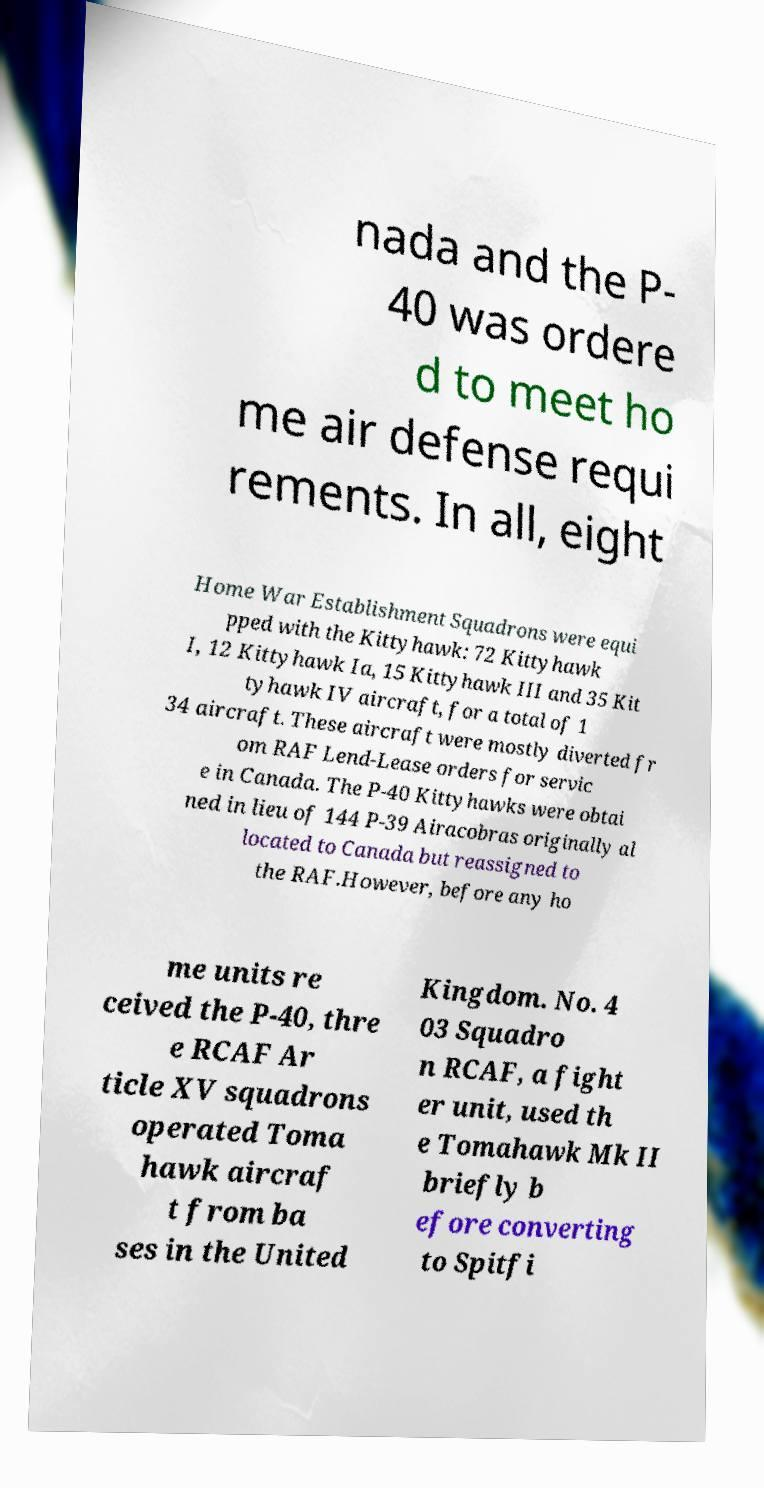Could you assist in decoding the text presented in this image and type it out clearly? nada and the P- 40 was ordere d to meet ho me air defense requi rements. In all, eight Home War Establishment Squadrons were equi pped with the Kittyhawk: 72 Kittyhawk I, 12 Kittyhawk Ia, 15 Kittyhawk III and 35 Kit tyhawk IV aircraft, for a total of 1 34 aircraft. These aircraft were mostly diverted fr om RAF Lend-Lease orders for servic e in Canada. The P-40 Kittyhawks were obtai ned in lieu of 144 P-39 Airacobras originally al located to Canada but reassigned to the RAF.However, before any ho me units re ceived the P-40, thre e RCAF Ar ticle XV squadrons operated Toma hawk aircraf t from ba ses in the United Kingdom. No. 4 03 Squadro n RCAF, a fight er unit, used th e Tomahawk Mk II briefly b efore converting to Spitfi 